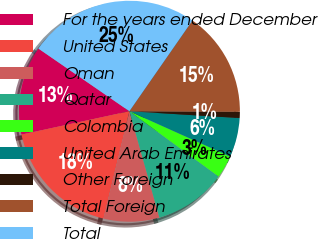Convert chart. <chart><loc_0><loc_0><loc_500><loc_500><pie_chart><fcel>For the years ended December<fcel>United States<fcel>Oman<fcel>Qatar<fcel>Colombia<fcel>United Arab Emirates<fcel>Other Foreign<fcel>Total Foreign<fcel>Total<nl><fcel>12.99%<fcel>17.82%<fcel>8.16%<fcel>10.57%<fcel>3.33%<fcel>5.74%<fcel>0.91%<fcel>15.41%<fcel>25.07%<nl></chart> 